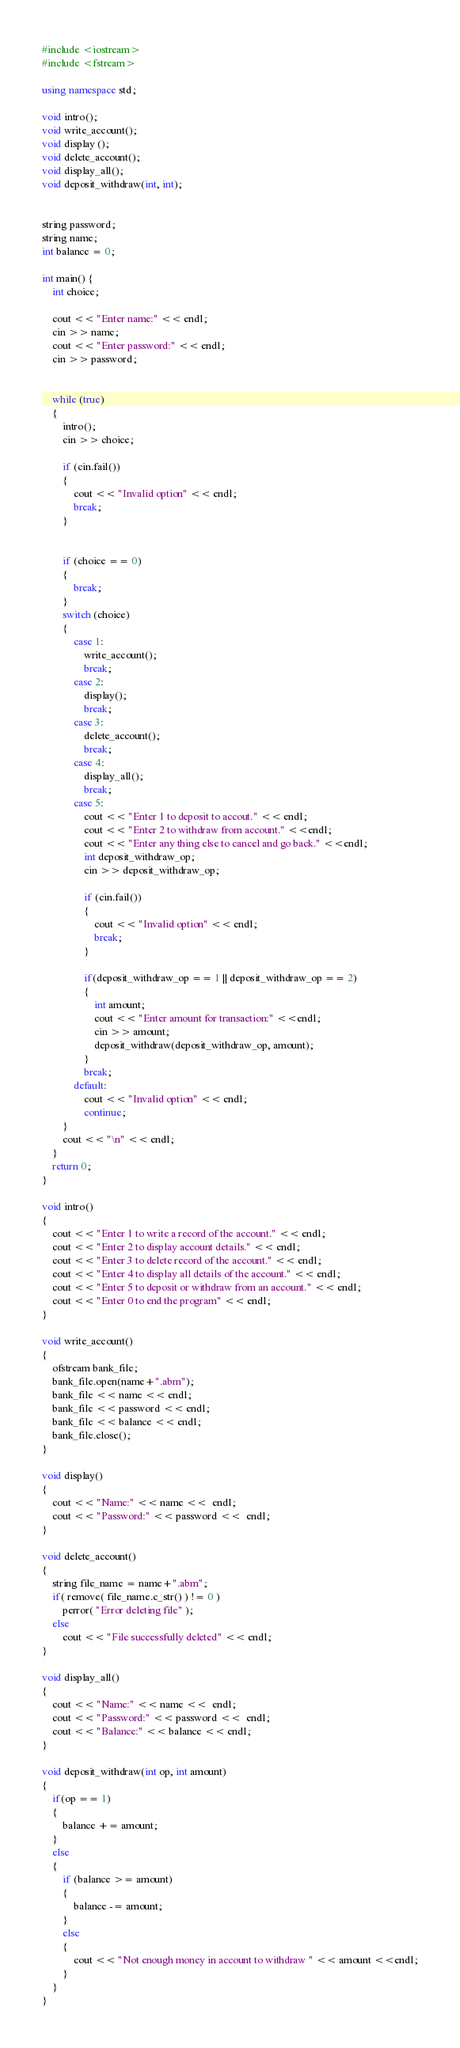Convert code to text. <code><loc_0><loc_0><loc_500><loc_500><_C++_>#include <iostream>
#include <fstream>

using namespace std;

void intro();
void write_account();
void display ();
void delete_account();
void display_all();
void deposit_withdraw(int, int);


string password;
string name;
int balance = 0;

int main() {
    int choice;

    cout << "Enter name:" << endl;
    cin >> name;
    cout << "Enter password:" << endl;
    cin >> password;


    while (true)
    {
        intro();
        cin >> choice;

        if (cin.fail())
        {
            cout << "Invalid option" << endl;
            break;
        }


        if (choice == 0)
        {
            break;
        }
        switch (choice)
        {
            case 1:
                write_account();
                break;
            case 2:
                display();
                break;
            case 3:
                delete_account();
                break;
            case 4:
                display_all();
                break;
            case 5:
                cout << "Enter 1 to deposit to accout." << endl;
                cout << "Enter 2 to withdraw from account." <<endl;
                cout << "Enter any thing else to cancel and go back." <<endl;
                int deposit_withdraw_op;
                cin >> deposit_withdraw_op;

                if (cin.fail())
                {
                    cout << "Invalid option" << endl;
                    break;
                }
                
                if(deposit_withdraw_op == 1 || deposit_withdraw_op == 2)
                {
                    int amount;
                    cout << "Enter amount for transaction:" <<endl;
                    cin >> amount;
                    deposit_withdraw(deposit_withdraw_op, amount);
                }
                break;
            default:
                cout << "Invalid option" << endl;
                continue;
        }
        cout << "\n" << endl;
    }
    return 0;
}

void intro()
{
    cout << "Enter 1 to write a record of the account." << endl;
    cout << "Enter 2 to display account details." << endl;
    cout << "Enter 3 to delete record of the account." << endl;
    cout << "Enter 4 to display all details of the account." << endl;
    cout << "Enter 5 to deposit or withdraw from an account." << endl;
    cout << "Enter 0 to end the program" << endl;
}

void write_account()
{
    ofstream bank_file;
    bank_file.open(name+".abm");
    bank_file << name << endl;
    bank_file << password << endl;
    bank_file << balance << endl;
    bank_file.close();
}

void display()
{
    cout << "Name:" << name <<  endl;
    cout << "Password:" << password <<  endl;
}

void delete_account()
{
    string file_name = name+".abm";
    if( remove( file_name.c_str() ) != 0 )
        perror( "Error deleting file" );
    else
        cout << "File successfully deleted" << endl;
}

void display_all()
{
    cout << "Name:" << name <<  endl;
    cout << "Password:" << password <<  endl;
    cout << "Balance:" << balance << endl;
}

void deposit_withdraw(int op, int amount)
{
    if(op == 1)
    {
        balance += amount;
    }
    else
    {
        if (balance >= amount)
        {
            balance -= amount;
        }
        else
        {
            cout << "Not enough money in account to withdraw " << amount <<endl;
        }
    }
}
</code> 